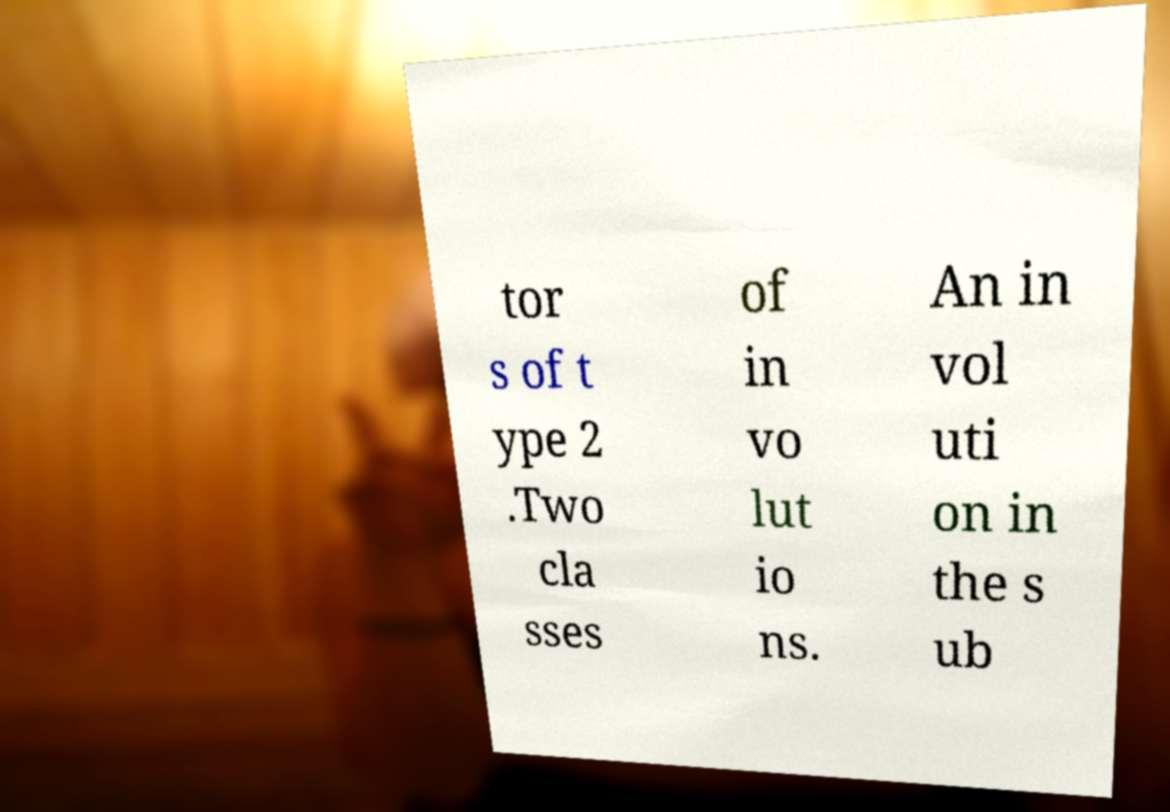Could you extract and type out the text from this image? tor s of t ype 2 .Two cla sses of in vo lut io ns. An in vol uti on in the s ub 